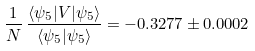<formula> <loc_0><loc_0><loc_500><loc_500>\frac { 1 } { N } \, \frac { \langle \psi _ { 5 } | V | \psi _ { 5 } \rangle } { \langle \psi _ { 5 } | \psi _ { 5 } \rangle } = - 0 . 3 2 7 7 \pm 0 . 0 0 0 2</formula> 